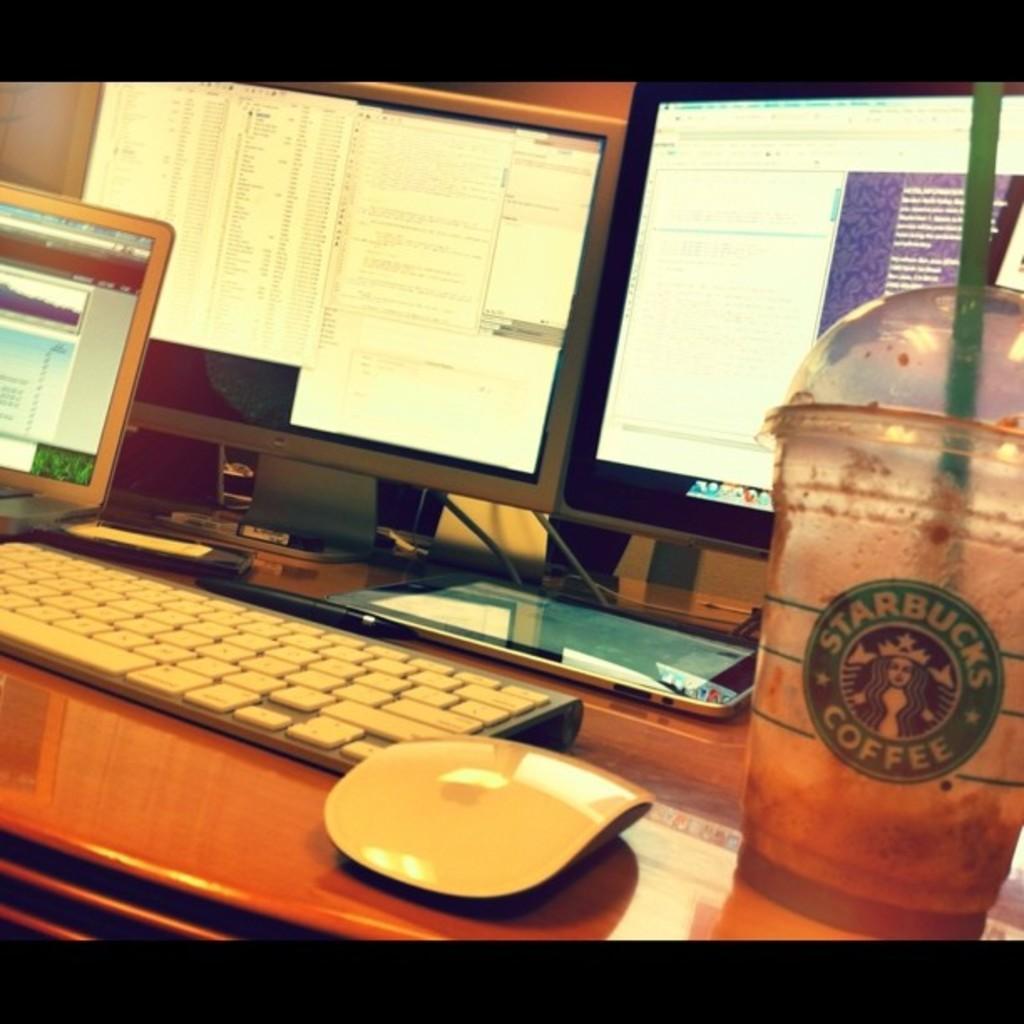Could you give a brief overview of what you see in this image? In this Picture we can see a Starbucks coffee cup, white color keyboard and mouse on the wooden table, Behind we can see three computer screens. 